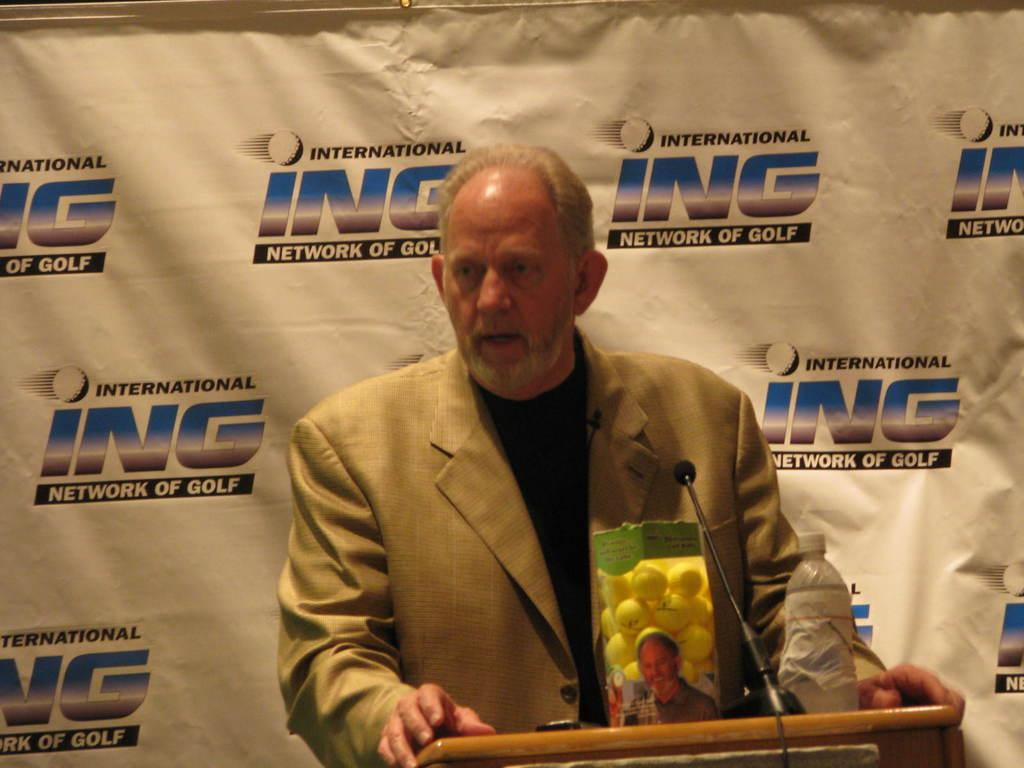Who is the main subject in the image? There is an old man in the image. What is the old man wearing? The old man is wearing a grey suit. Where is the old man standing in the image? The old man is standing in front of a dias. What is the old man doing in the image? The old man is talking on a mic. What can be seen on the wall behind the old man? There is a banner on the wall behind the old man. Can you see any cards being held by the old man in the image? There are no cards visible in the image; the old man is holding a mic. Is the old man standing near the ocean in the image? There is no ocean present in the image; it appears to be an indoor setting. 